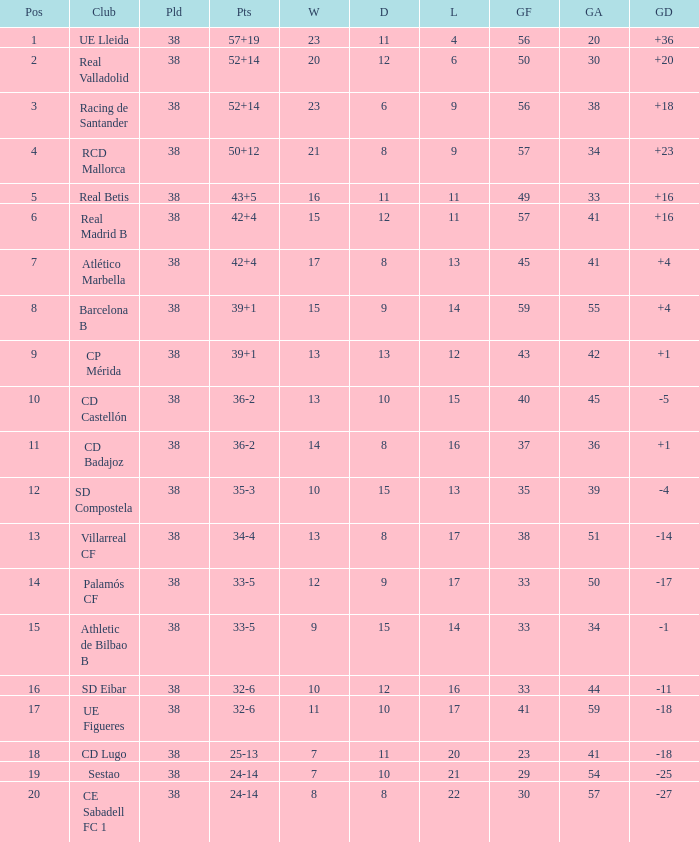What is the highest number of wins with a goal difference less than 4 at the Villarreal CF and more than 38 played? None. 